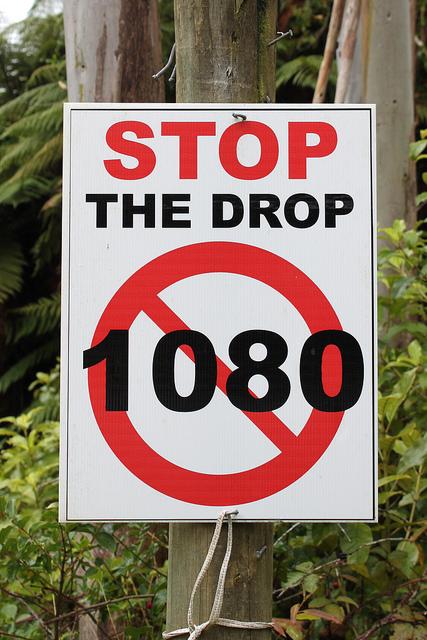What is the third word?
Be succinct. Drop. What color are the trees?
Concise answer only. Green. What is the sign hanging on?
Concise answer only. Pole. 